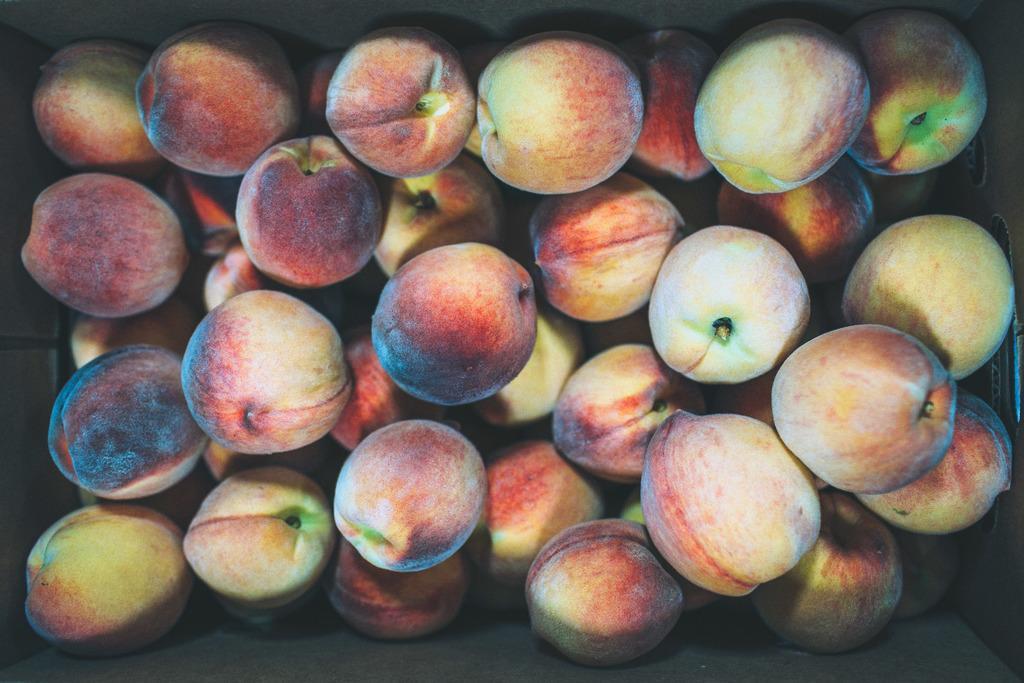Can you describe this image briefly? As we can see in the image, there are few fruits with red color. 